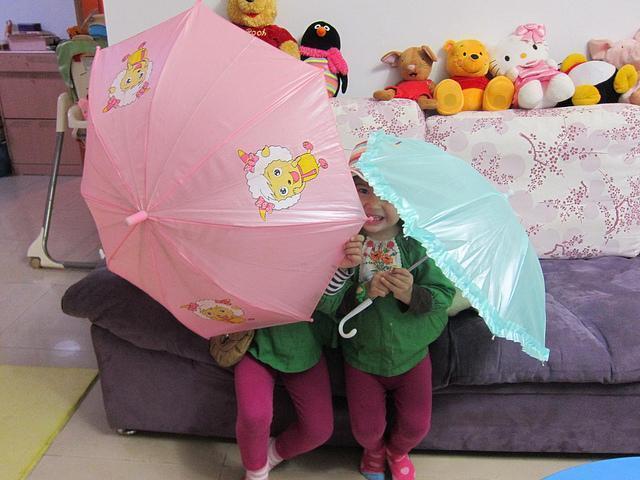How many teddy bears are in the picture?
Give a very brief answer. 4. How many people are in the photo?
Give a very brief answer. 2. How many umbrellas are in the picture?
Give a very brief answer. 2. 